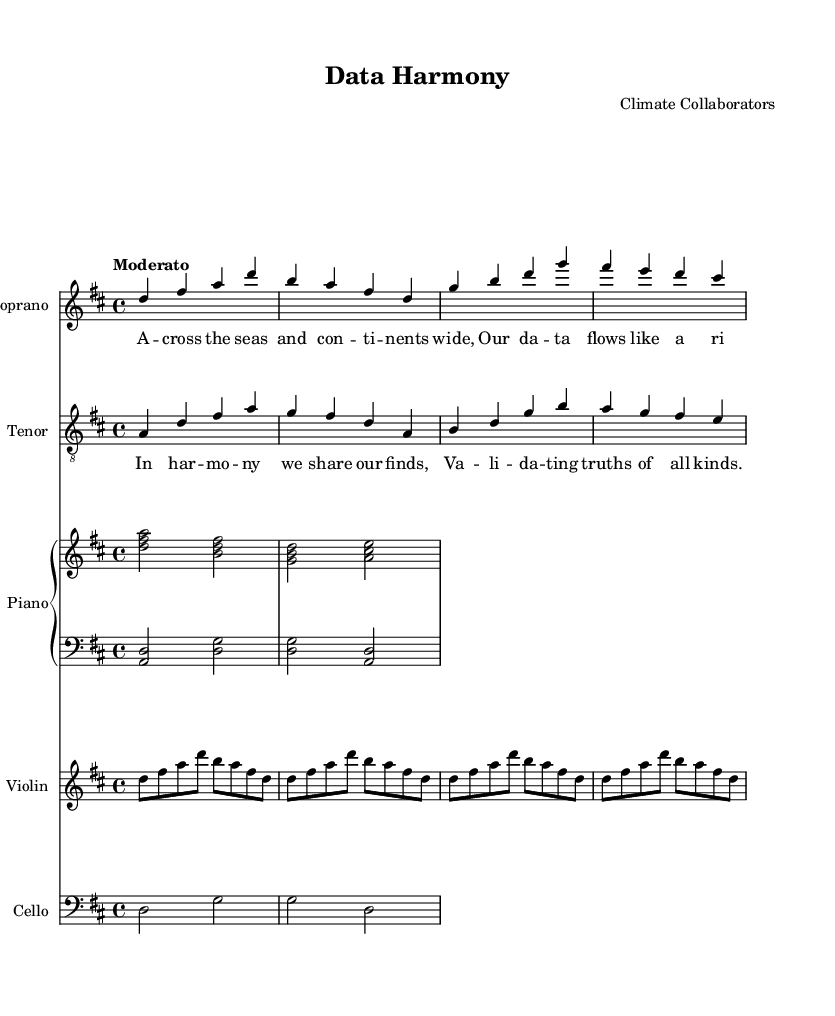What is the key signature of this music? The key signature is indicated at the beginning of the staff, showing two sharps (F# and C#), which signifies the key of D major.
Answer: D major What is the time signature of this music? The time signature is denoted right after the key signature, showing a "4/4" indication on the first measure, meaning there are four beats per measure, and the quarter note gets one beat.
Answer: 4/4 What is the tempo marking of this music? The tempo is specified with the word "Moderato" at the beginning, indicating a moderate pace to the performance of the piece.
Answer: Moderato How many measures are in the soprano part? Counting the measures in the soprano part, there are six measures before it transitions to the next part.
Answer: Six Which string instrument is included in this score? The score includes a violin and a cello, both notated with their designated staffs and clefs, with respective music written for them.
Answer: Violin and cello What are the lyrics associated with the soprano part? The lyrics for the soprano part are provided directly beneath the notes, stating "A cross the seas and con ti nents wide, Our da ta flows like a ri sing tide."
Answer: "A cross the seas and con ti nents wide, Our da ta flows like a ri sing tide." What is the theme of the chorus lyrics? The chorus lyrics emphasize the cooperative spirit and the factual validation that arises from sharing data, painted through the lines “In har mo ny we share our finds, Va li da ting truths of all kinds.”
Answer: Sharing data and validating truths 